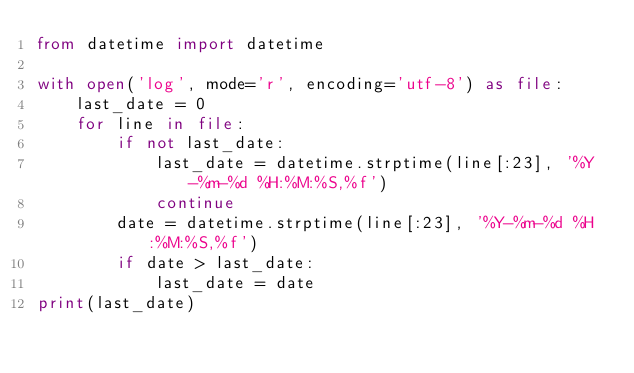<code> <loc_0><loc_0><loc_500><loc_500><_Python_>from datetime import datetime

with open('log', mode='r', encoding='utf-8') as file:
    last_date = 0
    for line in file:
        if not last_date:
            last_date = datetime.strptime(line[:23], '%Y-%m-%d %H:%M:%S,%f')
            continue
        date = datetime.strptime(line[:23], '%Y-%m-%d %H:%M:%S,%f')
        if date > last_date:
            last_date = date
print(last_date)
</code> 